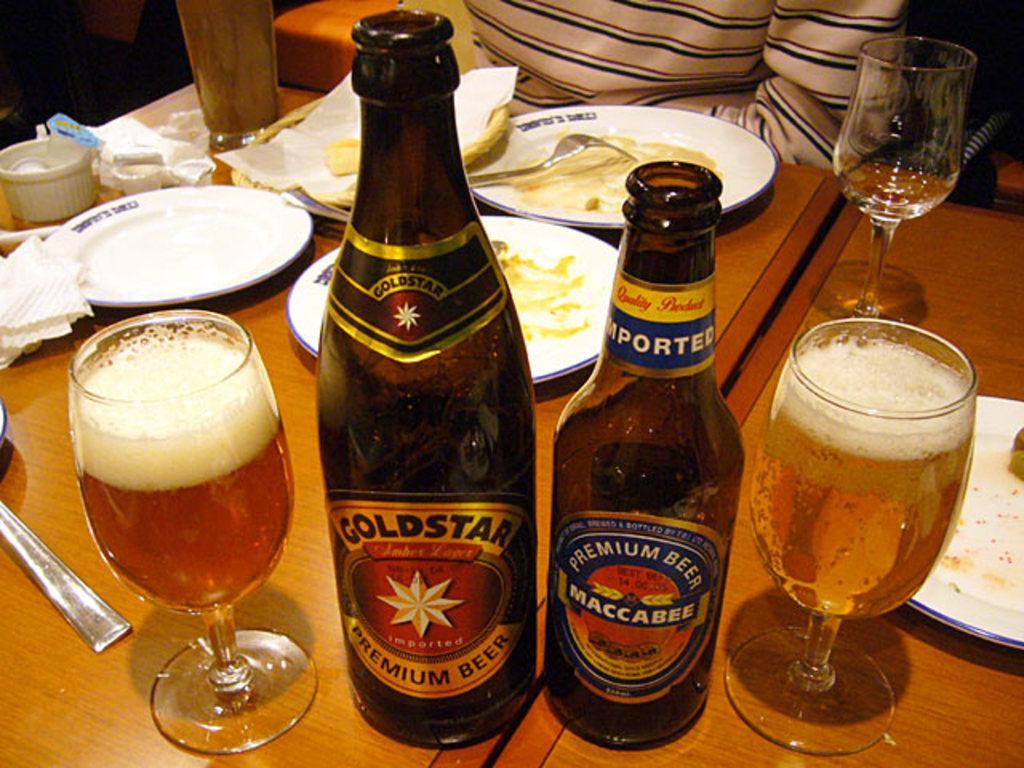In one or two sentences, can you explain what this image depicts? As we can see in the image there is a table. On table there are plates, glasses, bottles, cloth and dishes. 